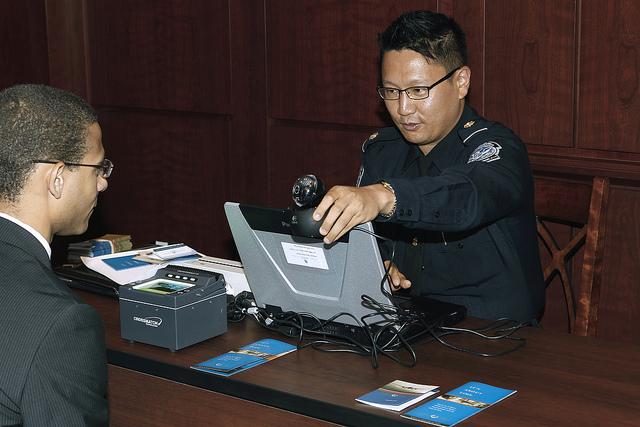What is the table made of?
Be succinct. Wood. What is the man in the suit looking at?
Answer briefly. Computer. How many people in this image are wearing glasses?
Quick response, please. 2. 